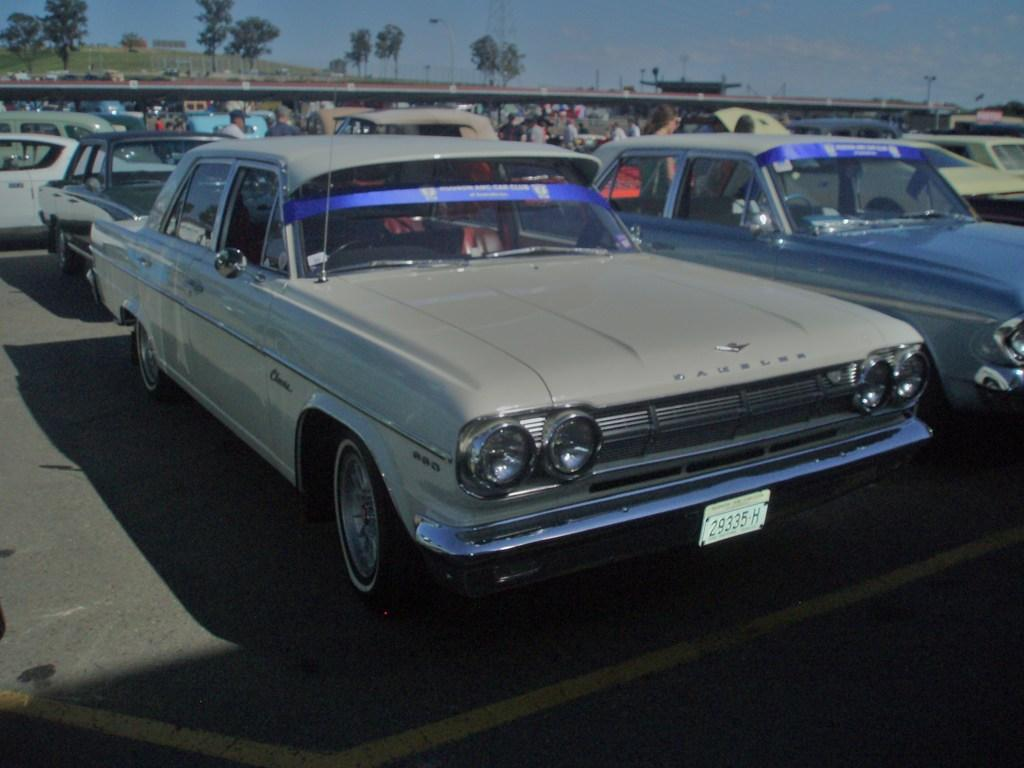<image>
Provide a brief description of the given image. A vintage grey car with a tag that reads 29335 H. 